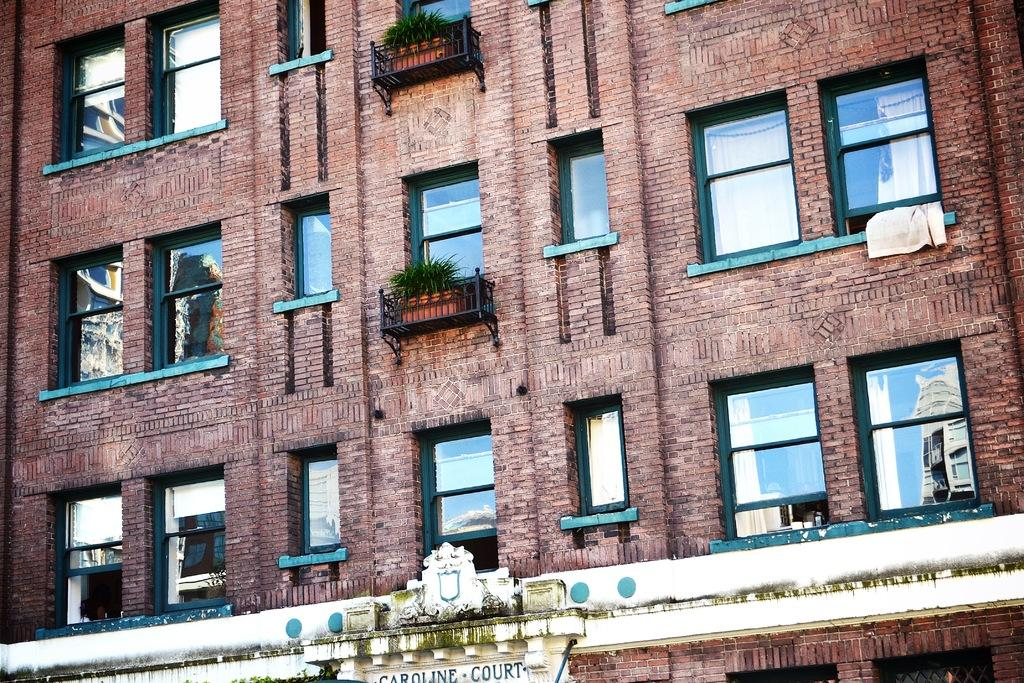What type of structure is present in the image? There is a building in the image. What feature can be seen on the building? The building has windows. What else is visible in the image besides the building? There are plants visible in the image. Is there any text or signage present in the image? Yes, there is a name board on the wall at the bottom of the image. How many fans are visible in the image? There are no fans present in the image. What type of shade is provided by the plants in the image? The image does not show any specific shade provided by the plants; it only shows their presence. 